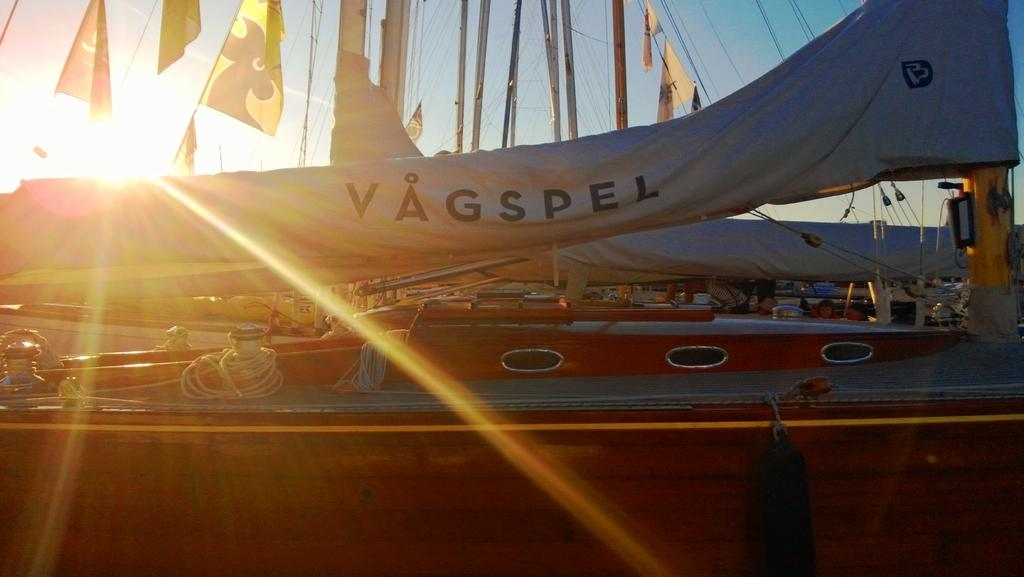<image>
Give a short and clear explanation of the subsequent image. The sail of a boat has the word Vagspel on it in thick black lettering. 